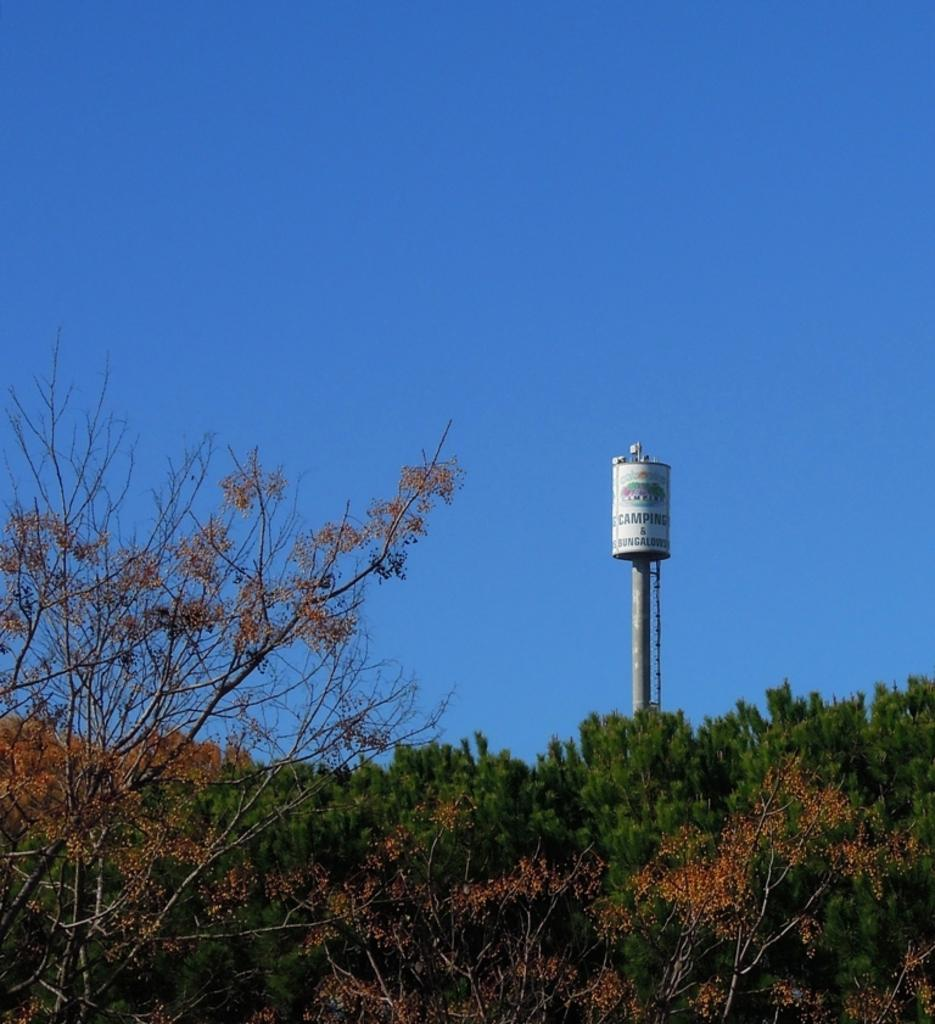What type of vegetation can be seen in the image? There are trees in the image. What structure is visible in the image? There is a water tower in the image. What is visible at the top of the image? The sky is visible at the top of the image. Where is the cat in the image? There is no cat present in the image. What type of attack is happening in the image? There is no attack depicted in the image; it features trees, a water tower, and the sky. 